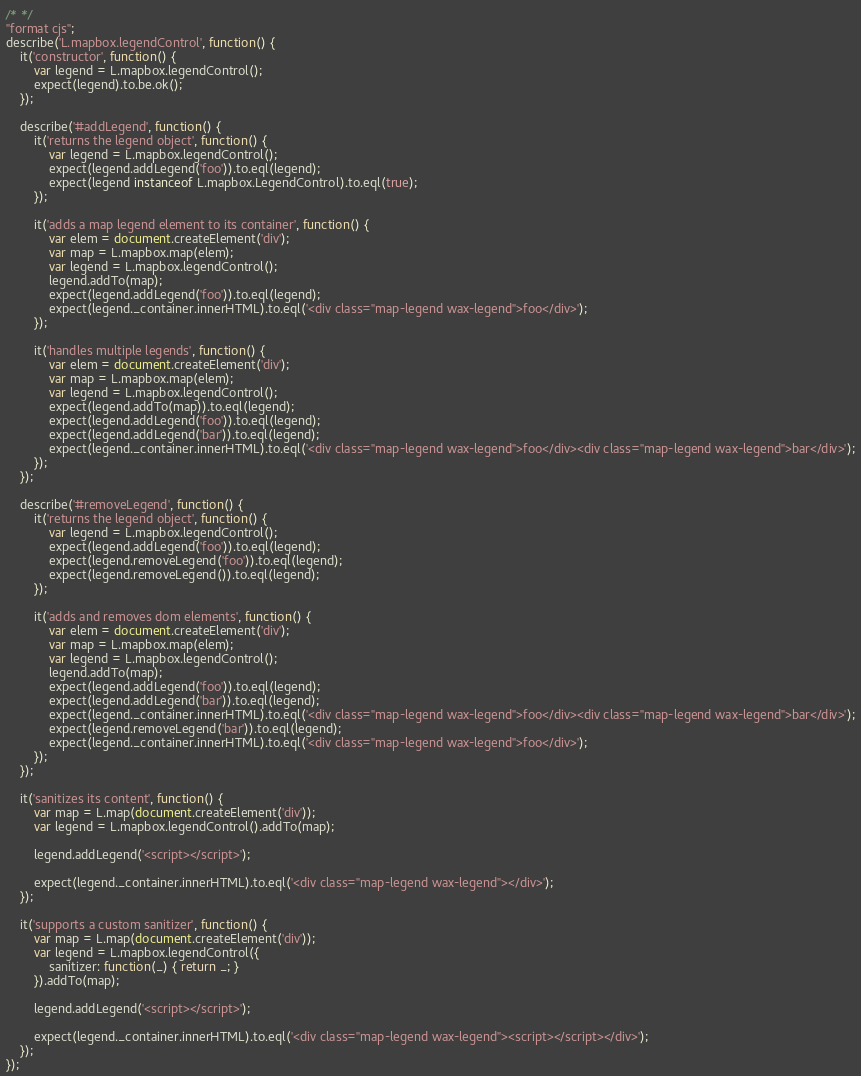<code> <loc_0><loc_0><loc_500><loc_500><_JavaScript_>/* */ 
"format cjs";
describe('L.mapbox.legendControl', function() {
    it('constructor', function() {
        var legend = L.mapbox.legendControl();
        expect(legend).to.be.ok();
    });

    describe('#addLegend', function() {
        it('returns the legend object', function() {
            var legend = L.mapbox.legendControl();
            expect(legend.addLegend('foo')).to.eql(legend);
            expect(legend instanceof L.mapbox.LegendControl).to.eql(true);
        });

        it('adds a map legend element to its container', function() {
            var elem = document.createElement('div');
            var map = L.mapbox.map(elem);
            var legend = L.mapbox.legendControl();
            legend.addTo(map);
            expect(legend.addLegend('foo')).to.eql(legend);
            expect(legend._container.innerHTML).to.eql('<div class="map-legend wax-legend">foo</div>');
        });

        it('handles multiple legends', function() {
            var elem = document.createElement('div');
            var map = L.mapbox.map(elem);
            var legend = L.mapbox.legendControl();
            expect(legend.addTo(map)).to.eql(legend);
            expect(legend.addLegend('foo')).to.eql(legend);
            expect(legend.addLegend('bar')).to.eql(legend);
            expect(legend._container.innerHTML).to.eql('<div class="map-legend wax-legend">foo</div><div class="map-legend wax-legend">bar</div>');
        });
    });

    describe('#removeLegend', function() {
        it('returns the legend object', function() {
            var legend = L.mapbox.legendControl();
            expect(legend.addLegend('foo')).to.eql(legend);
            expect(legend.removeLegend('foo')).to.eql(legend);
            expect(legend.removeLegend()).to.eql(legend);
        });

        it('adds and removes dom elements', function() {
            var elem = document.createElement('div');
            var map = L.mapbox.map(elem);
            var legend = L.mapbox.legendControl();
            legend.addTo(map);
            expect(legend.addLegend('foo')).to.eql(legend);
            expect(legend.addLegend('bar')).to.eql(legend);
            expect(legend._container.innerHTML).to.eql('<div class="map-legend wax-legend">foo</div><div class="map-legend wax-legend">bar</div>');
            expect(legend.removeLegend('bar')).to.eql(legend);
            expect(legend._container.innerHTML).to.eql('<div class="map-legend wax-legend">foo</div>');
        });
    });

    it('sanitizes its content', function() {
        var map = L.map(document.createElement('div'));
        var legend = L.mapbox.legendControl().addTo(map);

        legend.addLegend('<script></script>');

        expect(legend._container.innerHTML).to.eql('<div class="map-legend wax-legend"></div>');
    });

    it('supports a custom sanitizer', function() {
        var map = L.map(document.createElement('div'));
        var legend = L.mapbox.legendControl({
            sanitizer: function(_) { return _; }
        }).addTo(map);

        legend.addLegend('<script></script>');

        expect(legend._container.innerHTML).to.eql('<div class="map-legend wax-legend"><script></script></div>');
    });
});
</code> 